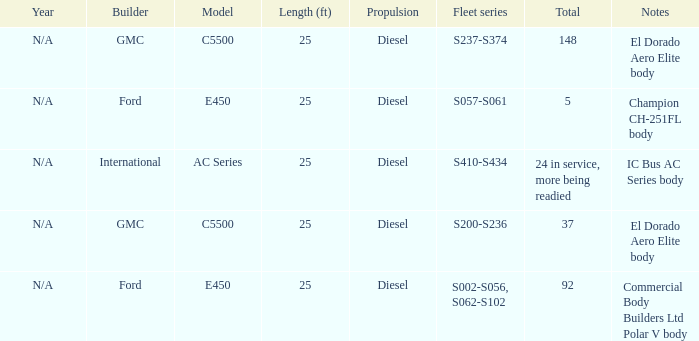Which builder has a fleet series of s057-s061? Ford. 